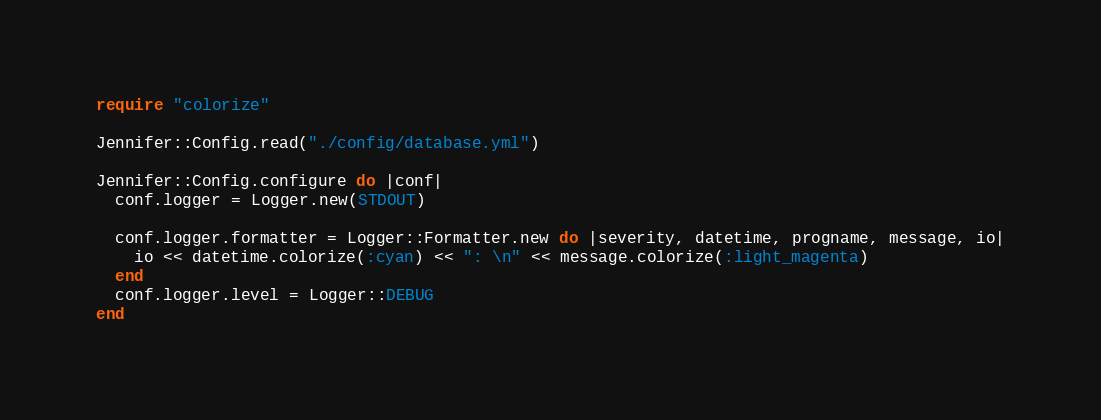Convert code to text. <code><loc_0><loc_0><loc_500><loc_500><_Crystal_>require "colorize"

Jennifer::Config.read("./config/database.yml")

Jennifer::Config.configure do |conf|
  conf.logger = Logger.new(STDOUT)

  conf.logger.formatter = Logger::Formatter.new do |severity, datetime, progname, message, io|
    io << datetime.colorize(:cyan) << ": \n" << message.colorize(:light_magenta)
  end
  conf.logger.level = Logger::DEBUG
end</code> 